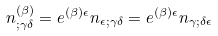Convert formula to latex. <formula><loc_0><loc_0><loc_500><loc_500>n ^ { ( \beta ) } _ { ; \gamma \delta } = e ^ { ( \beta ) \epsilon } n _ { \epsilon ; \gamma \delta } = e ^ { ( \beta ) \epsilon } n _ { \gamma ; \delta \epsilon }</formula> 